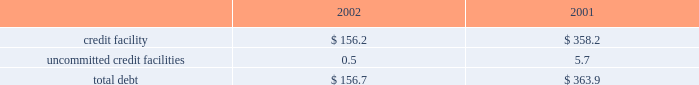Z i m m e r h o l d i n g s , i n c .
A n d s u b s i d i a r i e s 2 0 0 2 f o r m 1 0 - k notes to consolidated financial statements ( continued ) rating as of december 31 , 2002 met such requirement .
Fair value commitments under the credit facility are subject to certain the carrying value of the company 2019s borrowings approxi- fees , including a facility and a utilization fee .
Mates fair value due to their short-term maturities and uncommitted credit facilities variable interest rates .
The company has a $ 26 million uncommitted unsecured 8 .
Derivative financial instruments revolving line of credit .
The purpose of this credit line is to support the working capital needs , letters of credit and the company is exposed to market risk due to changes overdraft needs for the company .
The uncommitted credit in currency exchange rates .
As a result , the company utilizes agreement contains customary affirmative and negative cove- foreign exchange forward contracts to offset the effect of nants and events of default , none of which are considered exchange rate fluctuations on anticipated foreign currency restrictive to the operation of the business .
In addition , this transactions , primarily intercompany sales and purchases uncommitted credit agreement provides for unconditional expected to occur within the next twelve to twenty-four and irrevocable guarantees by the company .
In the event the months .
The company does not hold financial instruments company 2019s long-term debt ratings by both standard and for trading or speculative purposes .
For derivatives which poor 2019s ratings services and moody 2019s investor 2019s service , inc. , qualify as hedges of future cash flows , the effective portion fall below bb- and ba3 , then the company may be required of changes in fair value is temporarily recorded in other to repay all outstanding and contingent obligations .
The comprehensive income , then recognized in earnings when company 2019s credit rating as of december 31 , 2002 met such the hedged item affects earnings .
The ineffective portion of requirement .
This uncommitted credit line matures on a derivative 2019s change in fair value , if any , is reported in july 31 , 2003 .
Outstanding borrowings under this uncommit- earnings .
The net amount recognized in earnings during the ted line of credit as of december 31 , 2002 were $ 0.5 million years ended december 31 , 2002 and 2001 , due to ineffective- with a weighted average interest rate of 6.35 percent .
Ness and amounts excluded from the assessment of hedge the company also has a $ 15 million uncommitted effectiveness , was not significant .
Revolving unsecured line of credit .
The purpose of this line of the notional amounts of outstanding foreign exchange credit is to support short-term working capital needs of the forward contracts , principally japanese yen and the euro , company .
The agreement for this uncommitted unsecured entered into with third parties , at december 31 , 2002 , was line of credit contains customary covenants , none of which $ 252 million .
The fair value of derivative instruments recorded are considered restrictive to the operation of the business .
In accrued liabilities at december 31 , 2002 , was $ 13.8 million , this uncommitted line matures on july 31 , 2003 .
There were or $ 8.5 million net of taxes , which is deferred in other no borrowings under this uncommitted line of credit as of comprehensive income and is expected to be reclassified to december 31 , 2002 .
Earnings over the next two years , of which , $ 7.7 million , or the company has a $ 20 million uncommitted revolving $ 4.8 million , net of taxes , is expected to be reclassified to unsecured line of credit .
The purpose of this line of credit is earnings over the next twelve months .
To support short-term working capital needs of the company .
The pricing is based upon money market rates .
The agree- 9 .
Capital stock and earnings per share ment for this uncommitted unsecured line of credit contains as discussed in note 14 , all of the shares of company customary covenants , none of which are considered restrictive common stock were distributed at the distribution by the to the operation of the business .
This uncommitted line former parent to its stockholders in the form of a dividend matures on july 31 , 2003 .
There were no borrowings under of one share of company common stock , and the associated this uncommitted line of credit as of december 31 , 2002 .
Preferred stock purchase right , for every ten shares of the company was in compliance with all covenants common stock of the former parent .
In july 2001 the board under all three of the uncommitted credit facilities as of of directors of the company adopted a rights agreement december 31 , 2002 .
The company had no long-term debt intended to have anti-takeover effects .
Under this agreement as of december 31 , 2002 .
One right attaches to each share of company common stock .
Outstanding debt as of december 31 , 2002 and 2001 , the rights will not become exercisable until the earlier of : consist of the following ( in millions ) : a ) the company learns that a person or group acquired , or 2002 2001 obtained the right to acquire , beneficial ownership of securi- credit facility $ 156.2 $ 358.2 ties representing more than 20 percent of the shares of uncommitted credit facilities 0.5 5.7 company common stock then outstanding , or b ) such date , if any , as may be designated by the board of directorstotal debt $ 156.7 $ 363.9 following the commencement of , or first public disclosure of the company paid $ 13.0 million and $ 4.6 million in an intention to commence , a tender offer or exchange offer interest charges during 2002 and 2001 , respectively. .
Z i m m e r h o l d i n g s , i n c .
A n d s u b s i d i a r i e s 2 0 0 2 f o r m 1 0 - k notes to consolidated financial statements ( continued ) rating as of december 31 , 2002 met such requirement .
Fair value commitments under the credit facility are subject to certain the carrying value of the company 2019s borrowings approxi- fees , including a facility and a utilization fee .
Mates fair value due to their short-term maturities and uncommitted credit facilities variable interest rates .
The company has a $ 26 million uncommitted unsecured 8 .
Derivative financial instruments revolving line of credit .
The purpose of this credit line is to support the working capital needs , letters of credit and the company is exposed to market risk due to changes overdraft needs for the company .
The uncommitted credit in currency exchange rates .
As a result , the company utilizes agreement contains customary affirmative and negative cove- foreign exchange forward contracts to offset the effect of nants and events of default , none of which are considered exchange rate fluctuations on anticipated foreign currency restrictive to the operation of the business .
In addition , this transactions , primarily intercompany sales and purchases uncommitted credit agreement provides for unconditional expected to occur within the next twelve to twenty-four and irrevocable guarantees by the company .
In the event the months .
The company does not hold financial instruments company 2019s long-term debt ratings by both standard and for trading or speculative purposes .
For derivatives which poor 2019s ratings services and moody 2019s investor 2019s service , inc. , qualify as hedges of future cash flows , the effective portion fall below bb- and ba3 , then the company may be required of changes in fair value is temporarily recorded in other to repay all outstanding and contingent obligations .
The comprehensive income , then recognized in earnings when company 2019s credit rating as of december 31 , 2002 met such the hedged item affects earnings .
The ineffective portion of requirement .
This uncommitted credit line matures on a derivative 2019s change in fair value , if any , is reported in july 31 , 2003 .
Outstanding borrowings under this uncommit- earnings .
The net amount recognized in earnings during the ted line of credit as of december 31 , 2002 were $ 0.5 million years ended december 31 , 2002 and 2001 , due to ineffective- with a weighted average interest rate of 6.35 percent .
Ness and amounts excluded from the assessment of hedge the company also has a $ 15 million uncommitted effectiveness , was not significant .
Revolving unsecured line of credit .
The purpose of this line of the notional amounts of outstanding foreign exchange credit is to support short-term working capital needs of the forward contracts , principally japanese yen and the euro , company .
The agreement for this uncommitted unsecured entered into with third parties , at december 31 , 2002 , was line of credit contains customary covenants , none of which $ 252 million .
The fair value of derivative instruments recorded are considered restrictive to the operation of the business .
In accrued liabilities at december 31 , 2002 , was $ 13.8 million , this uncommitted line matures on july 31 , 2003 .
There were or $ 8.5 million net of taxes , which is deferred in other no borrowings under this uncommitted line of credit as of comprehensive income and is expected to be reclassified to december 31 , 2002 .
Earnings over the next two years , of which , $ 7.7 million , or the company has a $ 20 million uncommitted revolving $ 4.8 million , net of taxes , is expected to be reclassified to unsecured line of credit .
The purpose of this line of credit is earnings over the next twelve months .
To support short-term working capital needs of the company .
The pricing is based upon money market rates .
The agree- 9 .
Capital stock and earnings per share ment for this uncommitted unsecured line of credit contains as discussed in note 14 , all of the shares of company customary covenants , none of which are considered restrictive common stock were distributed at the distribution by the to the operation of the business .
This uncommitted line former parent to its stockholders in the form of a dividend matures on july 31 , 2003 .
There were no borrowings under of one share of company common stock , and the associated this uncommitted line of credit as of december 31 , 2002 .
Preferred stock purchase right , for every ten shares of the company was in compliance with all covenants common stock of the former parent .
In july 2001 the board under all three of the uncommitted credit facilities as of of directors of the company adopted a rights agreement december 31 , 2002 .
The company had no long-term debt intended to have anti-takeover effects .
Under this agreement as of december 31 , 2002 .
One right attaches to each share of company common stock .
Outstanding debt as of december 31 , 2002 and 2001 , the rights will not become exercisable until the earlier of : consist of the following ( in millions ) : a ) the company learns that a person or group acquired , or 2002 2001 obtained the right to acquire , beneficial ownership of securi- credit facility $ 156.2 $ 358.2 ties representing more than 20 percent of the shares of uncommitted credit facilities 0.5 5.7 company common stock then outstanding , or b ) such date , if any , as may be designated by the board of directorstotal debt $ 156.7 $ 363.9 following the commencement of , or first public disclosure of the company paid $ 13.0 million and $ 4.6 million in an intention to commence , a tender offer or exchange offer interest charges during 2002 and 2001 , respectively. .
What was the net change in millions of total debt from 2001 to 2002? 
Computations: (156.7 - 363.9)
Answer: -207.2. 